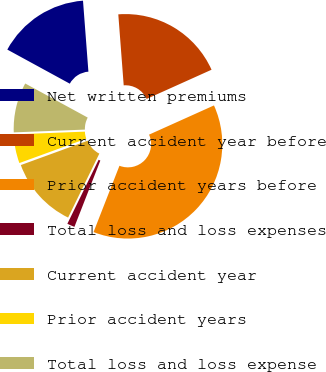Convert chart. <chart><loc_0><loc_0><loc_500><loc_500><pie_chart><fcel>Net written premiums<fcel>Current accident year before<fcel>Prior accident years before<fcel>Total loss and loss expenses<fcel>Current accident year<fcel>Prior accident years<fcel>Total loss and loss expense<nl><fcel>15.84%<fcel>19.48%<fcel>37.66%<fcel>1.3%<fcel>12.21%<fcel>4.94%<fcel>8.57%<nl></chart> 